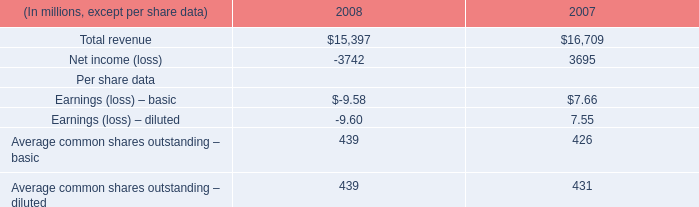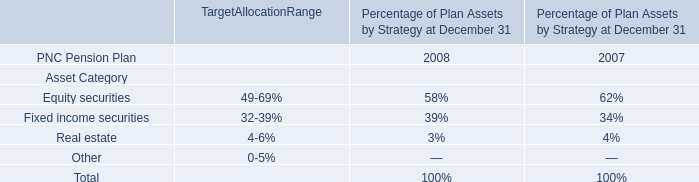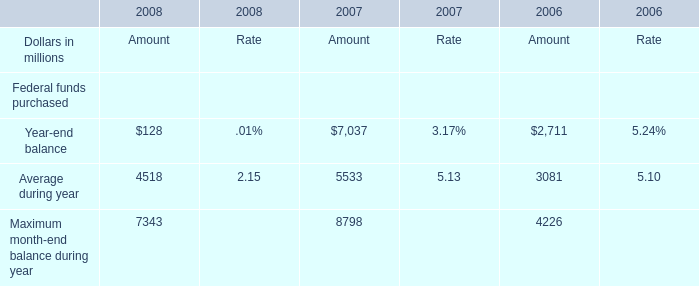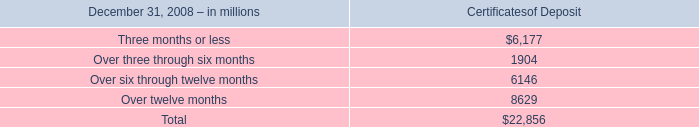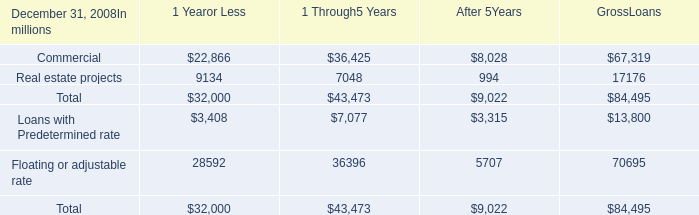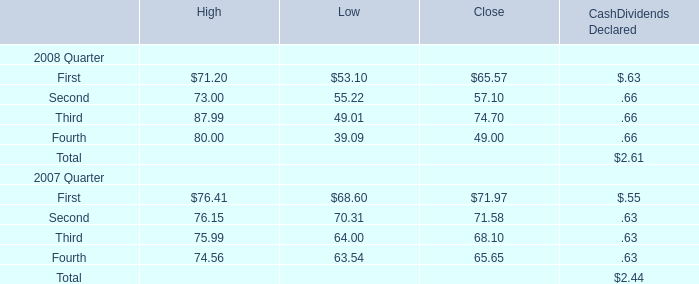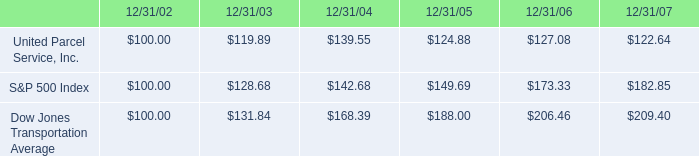What's the sum of all elements that are greater than 6000 in 2008? (in million) 
Computations: ((6177 + 6146) + 8629)
Answer: 20952.0. 